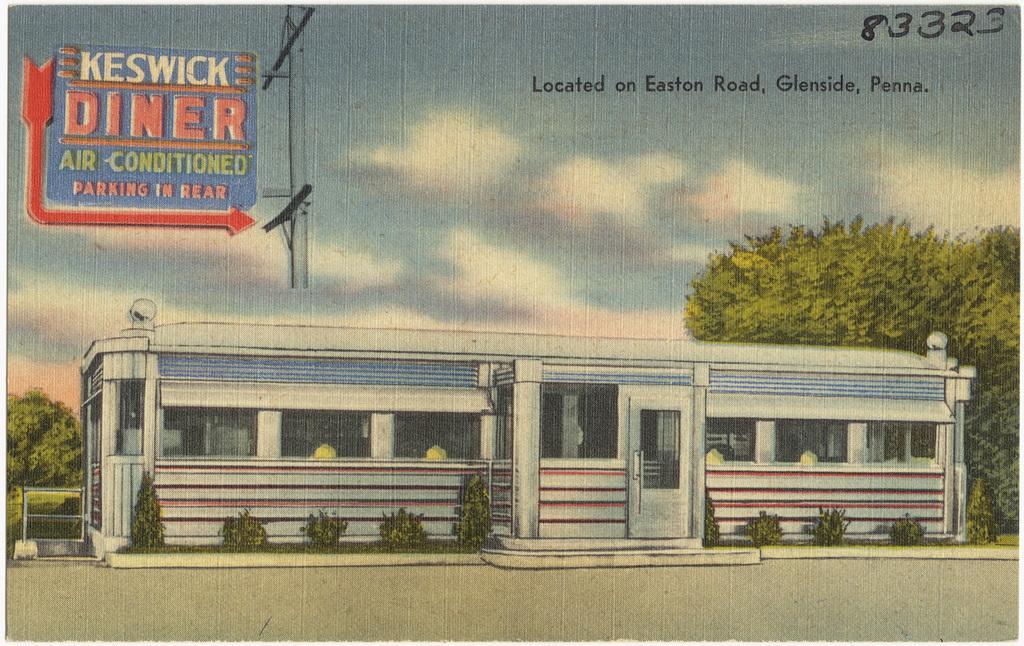In one or two sentences, can you explain what this image depicts? In this image I can see a building in white color. Background I can see trees in green color and sky in white and blue color. I can also see a blue color board attached to a pole. 